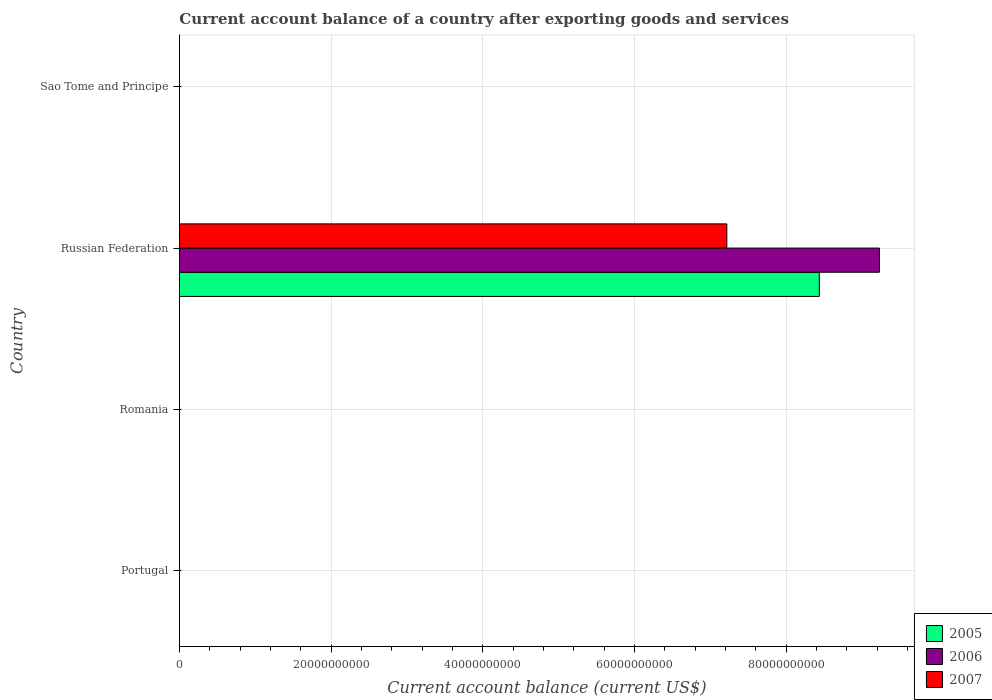How many different coloured bars are there?
Keep it short and to the point. 3. What is the label of the 3rd group of bars from the top?
Provide a succinct answer. Romania. Across all countries, what is the maximum account balance in 2006?
Keep it short and to the point. 9.23e+1. Across all countries, what is the minimum account balance in 2007?
Give a very brief answer. 0. In which country was the account balance in 2005 maximum?
Make the answer very short. Russian Federation. What is the total account balance in 2007 in the graph?
Provide a succinct answer. 7.22e+1. What is the average account balance in 2006 per country?
Your response must be concise. 2.31e+1. What is the difference between the account balance in 2006 and account balance in 2007 in Russian Federation?
Offer a terse response. 2.01e+1. In how many countries, is the account balance in 2005 greater than 48000000000 US$?
Offer a terse response. 1. What is the difference between the highest and the lowest account balance in 2005?
Your answer should be very brief. 8.44e+1. Is it the case that in every country, the sum of the account balance in 2005 and account balance in 2007 is greater than the account balance in 2006?
Provide a short and direct response. No. Does the graph contain any zero values?
Provide a succinct answer. Yes. What is the title of the graph?
Ensure brevity in your answer.  Current account balance of a country after exporting goods and services. Does "1992" appear as one of the legend labels in the graph?
Make the answer very short. No. What is the label or title of the X-axis?
Keep it short and to the point. Current account balance (current US$). What is the Current account balance (current US$) of 2005 in Portugal?
Keep it short and to the point. 0. What is the Current account balance (current US$) in 2006 in Romania?
Offer a terse response. 0. What is the Current account balance (current US$) in 2005 in Russian Federation?
Ensure brevity in your answer.  8.44e+1. What is the Current account balance (current US$) in 2006 in Russian Federation?
Offer a very short reply. 9.23e+1. What is the Current account balance (current US$) of 2007 in Russian Federation?
Your answer should be very brief. 7.22e+1. What is the Current account balance (current US$) in 2006 in Sao Tome and Principe?
Give a very brief answer. 0. What is the Current account balance (current US$) of 2007 in Sao Tome and Principe?
Give a very brief answer. 0. Across all countries, what is the maximum Current account balance (current US$) in 2005?
Make the answer very short. 8.44e+1. Across all countries, what is the maximum Current account balance (current US$) in 2006?
Your answer should be compact. 9.23e+1. Across all countries, what is the maximum Current account balance (current US$) in 2007?
Offer a terse response. 7.22e+1. What is the total Current account balance (current US$) of 2005 in the graph?
Your answer should be very brief. 8.44e+1. What is the total Current account balance (current US$) in 2006 in the graph?
Give a very brief answer. 9.23e+1. What is the total Current account balance (current US$) in 2007 in the graph?
Make the answer very short. 7.22e+1. What is the average Current account balance (current US$) of 2005 per country?
Make the answer very short. 2.11e+1. What is the average Current account balance (current US$) of 2006 per country?
Make the answer very short. 2.31e+1. What is the average Current account balance (current US$) of 2007 per country?
Your response must be concise. 1.80e+1. What is the difference between the Current account balance (current US$) in 2005 and Current account balance (current US$) in 2006 in Russian Federation?
Provide a short and direct response. -7.93e+09. What is the difference between the Current account balance (current US$) in 2005 and Current account balance (current US$) in 2007 in Russian Federation?
Keep it short and to the point. 1.22e+1. What is the difference between the Current account balance (current US$) of 2006 and Current account balance (current US$) of 2007 in Russian Federation?
Ensure brevity in your answer.  2.01e+1. What is the difference between the highest and the lowest Current account balance (current US$) of 2005?
Your answer should be compact. 8.44e+1. What is the difference between the highest and the lowest Current account balance (current US$) of 2006?
Keep it short and to the point. 9.23e+1. What is the difference between the highest and the lowest Current account balance (current US$) in 2007?
Ensure brevity in your answer.  7.22e+1. 